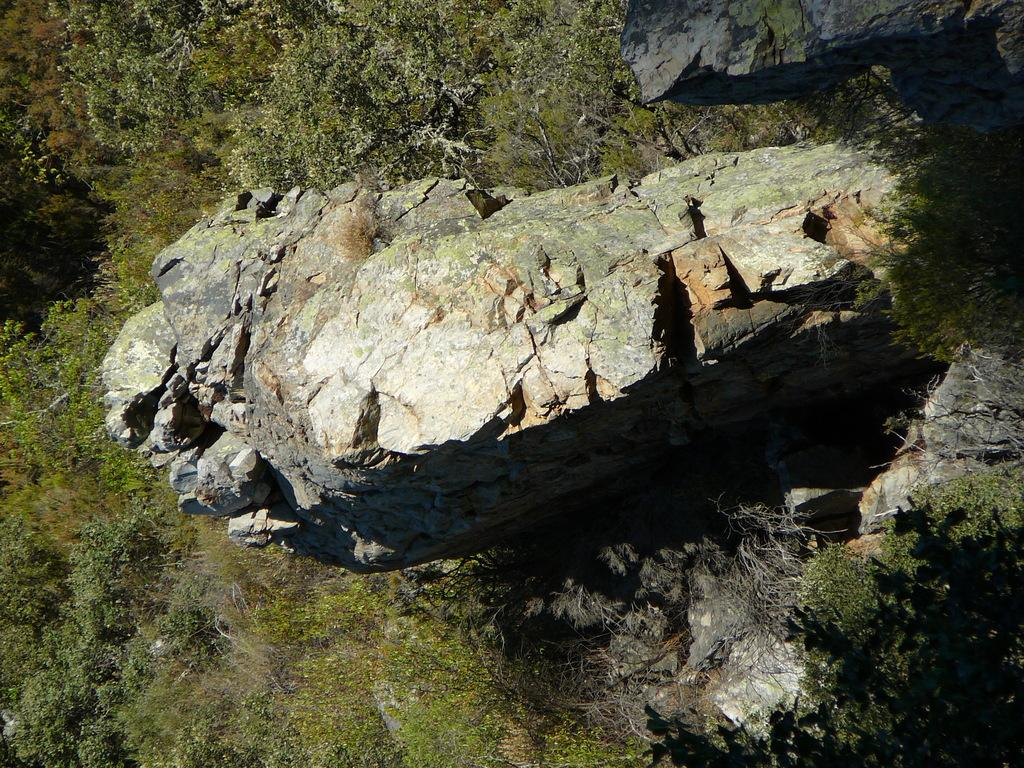What type of natural elements can be seen in the image? There are rocks and trees in the image. Can you describe the rocks in the image? The rocks in the image are likely part of the landscape or terrain. What type of vegetation is present in the image? Trees are the type of vegetation present in the image. What type of plastic item can be seen in the image? There is no plastic item present in the image. How many visitors are visible in the image? There are no visitors present in the image. 